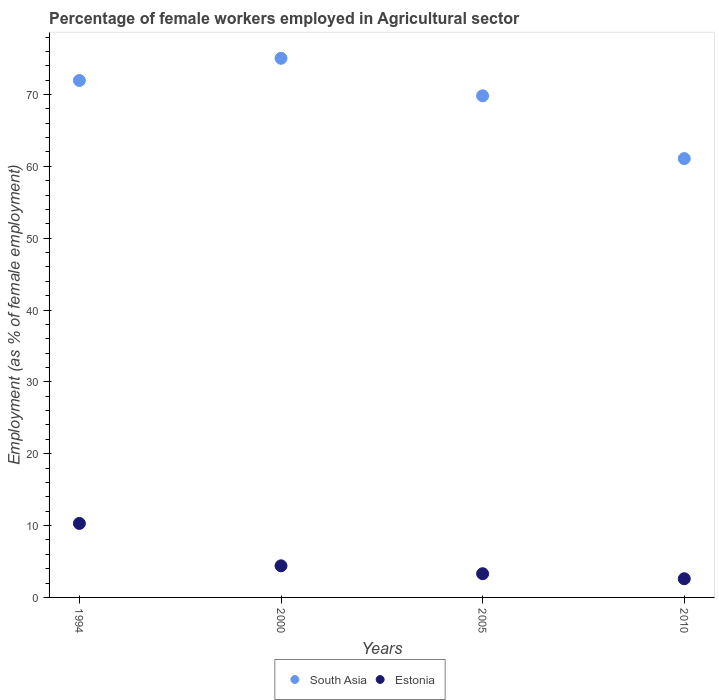Is the number of dotlines equal to the number of legend labels?
Give a very brief answer. Yes. What is the percentage of females employed in Agricultural sector in Estonia in 2005?
Make the answer very short. 3.3. Across all years, what is the maximum percentage of females employed in Agricultural sector in South Asia?
Ensure brevity in your answer.  75.04. Across all years, what is the minimum percentage of females employed in Agricultural sector in Estonia?
Offer a very short reply. 2.6. In which year was the percentage of females employed in Agricultural sector in Estonia maximum?
Your answer should be very brief. 1994. What is the total percentage of females employed in Agricultural sector in Estonia in the graph?
Keep it short and to the point. 20.6. What is the difference between the percentage of females employed in Agricultural sector in Estonia in 2005 and that in 2010?
Give a very brief answer. 0.7. What is the difference between the percentage of females employed in Agricultural sector in Estonia in 1994 and the percentage of females employed in Agricultural sector in South Asia in 2000?
Ensure brevity in your answer.  -64.74. What is the average percentage of females employed in Agricultural sector in South Asia per year?
Your answer should be very brief. 69.47. In the year 2010, what is the difference between the percentage of females employed in Agricultural sector in South Asia and percentage of females employed in Agricultural sector in Estonia?
Provide a succinct answer. 58.48. In how many years, is the percentage of females employed in Agricultural sector in Estonia greater than 14 %?
Your response must be concise. 0. What is the ratio of the percentage of females employed in Agricultural sector in South Asia in 2000 to that in 2010?
Keep it short and to the point. 1.23. What is the difference between the highest and the second highest percentage of females employed in Agricultural sector in South Asia?
Make the answer very short. 3.09. What is the difference between the highest and the lowest percentage of females employed in Agricultural sector in Estonia?
Ensure brevity in your answer.  7.7. In how many years, is the percentage of females employed in Agricultural sector in Estonia greater than the average percentage of females employed in Agricultural sector in Estonia taken over all years?
Your answer should be compact. 1. Does the percentage of females employed in Agricultural sector in Estonia monotonically increase over the years?
Offer a very short reply. No. Is the percentage of females employed in Agricultural sector in Estonia strictly greater than the percentage of females employed in Agricultural sector in South Asia over the years?
Your response must be concise. No. How many years are there in the graph?
Your answer should be very brief. 4. Are the values on the major ticks of Y-axis written in scientific E-notation?
Your answer should be compact. No. Does the graph contain any zero values?
Ensure brevity in your answer.  No. Where does the legend appear in the graph?
Provide a short and direct response. Bottom center. How are the legend labels stacked?
Ensure brevity in your answer.  Horizontal. What is the title of the graph?
Offer a terse response. Percentage of female workers employed in Agricultural sector. Does "Burundi" appear as one of the legend labels in the graph?
Keep it short and to the point. No. What is the label or title of the Y-axis?
Ensure brevity in your answer.  Employment (as % of female employment). What is the Employment (as % of female employment) of South Asia in 1994?
Your answer should be compact. 71.95. What is the Employment (as % of female employment) of Estonia in 1994?
Offer a terse response. 10.3. What is the Employment (as % of female employment) of South Asia in 2000?
Give a very brief answer. 75.04. What is the Employment (as % of female employment) of Estonia in 2000?
Offer a terse response. 4.4. What is the Employment (as % of female employment) in South Asia in 2005?
Your answer should be compact. 69.82. What is the Employment (as % of female employment) in Estonia in 2005?
Offer a terse response. 3.3. What is the Employment (as % of female employment) of South Asia in 2010?
Your answer should be compact. 61.08. What is the Employment (as % of female employment) of Estonia in 2010?
Provide a succinct answer. 2.6. Across all years, what is the maximum Employment (as % of female employment) of South Asia?
Ensure brevity in your answer.  75.04. Across all years, what is the maximum Employment (as % of female employment) of Estonia?
Your answer should be compact. 10.3. Across all years, what is the minimum Employment (as % of female employment) in South Asia?
Your response must be concise. 61.08. Across all years, what is the minimum Employment (as % of female employment) of Estonia?
Your answer should be compact. 2.6. What is the total Employment (as % of female employment) in South Asia in the graph?
Give a very brief answer. 277.89. What is the total Employment (as % of female employment) in Estonia in the graph?
Make the answer very short. 20.6. What is the difference between the Employment (as % of female employment) of South Asia in 1994 and that in 2000?
Provide a short and direct response. -3.09. What is the difference between the Employment (as % of female employment) in Estonia in 1994 and that in 2000?
Provide a succinct answer. 5.9. What is the difference between the Employment (as % of female employment) of South Asia in 1994 and that in 2005?
Offer a terse response. 2.13. What is the difference between the Employment (as % of female employment) of Estonia in 1994 and that in 2005?
Your answer should be compact. 7. What is the difference between the Employment (as % of female employment) of South Asia in 1994 and that in 2010?
Your response must be concise. 10.87. What is the difference between the Employment (as % of female employment) in Estonia in 1994 and that in 2010?
Your answer should be compact. 7.7. What is the difference between the Employment (as % of female employment) of South Asia in 2000 and that in 2005?
Provide a short and direct response. 5.22. What is the difference between the Employment (as % of female employment) of South Asia in 2000 and that in 2010?
Your response must be concise. 13.96. What is the difference between the Employment (as % of female employment) of South Asia in 2005 and that in 2010?
Give a very brief answer. 8.74. What is the difference between the Employment (as % of female employment) of Estonia in 2005 and that in 2010?
Provide a succinct answer. 0.7. What is the difference between the Employment (as % of female employment) in South Asia in 1994 and the Employment (as % of female employment) in Estonia in 2000?
Provide a short and direct response. 67.55. What is the difference between the Employment (as % of female employment) in South Asia in 1994 and the Employment (as % of female employment) in Estonia in 2005?
Offer a terse response. 68.65. What is the difference between the Employment (as % of female employment) in South Asia in 1994 and the Employment (as % of female employment) in Estonia in 2010?
Provide a short and direct response. 69.35. What is the difference between the Employment (as % of female employment) in South Asia in 2000 and the Employment (as % of female employment) in Estonia in 2005?
Offer a very short reply. 71.74. What is the difference between the Employment (as % of female employment) in South Asia in 2000 and the Employment (as % of female employment) in Estonia in 2010?
Your answer should be very brief. 72.44. What is the difference between the Employment (as % of female employment) of South Asia in 2005 and the Employment (as % of female employment) of Estonia in 2010?
Offer a terse response. 67.22. What is the average Employment (as % of female employment) in South Asia per year?
Keep it short and to the point. 69.47. What is the average Employment (as % of female employment) in Estonia per year?
Give a very brief answer. 5.15. In the year 1994, what is the difference between the Employment (as % of female employment) in South Asia and Employment (as % of female employment) in Estonia?
Offer a terse response. 61.65. In the year 2000, what is the difference between the Employment (as % of female employment) in South Asia and Employment (as % of female employment) in Estonia?
Provide a short and direct response. 70.64. In the year 2005, what is the difference between the Employment (as % of female employment) in South Asia and Employment (as % of female employment) in Estonia?
Your answer should be compact. 66.52. In the year 2010, what is the difference between the Employment (as % of female employment) of South Asia and Employment (as % of female employment) of Estonia?
Your response must be concise. 58.48. What is the ratio of the Employment (as % of female employment) of South Asia in 1994 to that in 2000?
Make the answer very short. 0.96. What is the ratio of the Employment (as % of female employment) of Estonia in 1994 to that in 2000?
Provide a short and direct response. 2.34. What is the ratio of the Employment (as % of female employment) in South Asia in 1994 to that in 2005?
Give a very brief answer. 1.03. What is the ratio of the Employment (as % of female employment) in Estonia in 1994 to that in 2005?
Your answer should be very brief. 3.12. What is the ratio of the Employment (as % of female employment) of South Asia in 1994 to that in 2010?
Give a very brief answer. 1.18. What is the ratio of the Employment (as % of female employment) of Estonia in 1994 to that in 2010?
Provide a short and direct response. 3.96. What is the ratio of the Employment (as % of female employment) of South Asia in 2000 to that in 2005?
Make the answer very short. 1.07. What is the ratio of the Employment (as % of female employment) in South Asia in 2000 to that in 2010?
Your answer should be very brief. 1.23. What is the ratio of the Employment (as % of female employment) in Estonia in 2000 to that in 2010?
Your answer should be compact. 1.69. What is the ratio of the Employment (as % of female employment) of South Asia in 2005 to that in 2010?
Give a very brief answer. 1.14. What is the ratio of the Employment (as % of female employment) of Estonia in 2005 to that in 2010?
Your answer should be compact. 1.27. What is the difference between the highest and the second highest Employment (as % of female employment) in South Asia?
Your response must be concise. 3.09. What is the difference between the highest and the second highest Employment (as % of female employment) of Estonia?
Your answer should be very brief. 5.9. What is the difference between the highest and the lowest Employment (as % of female employment) of South Asia?
Your response must be concise. 13.96. 